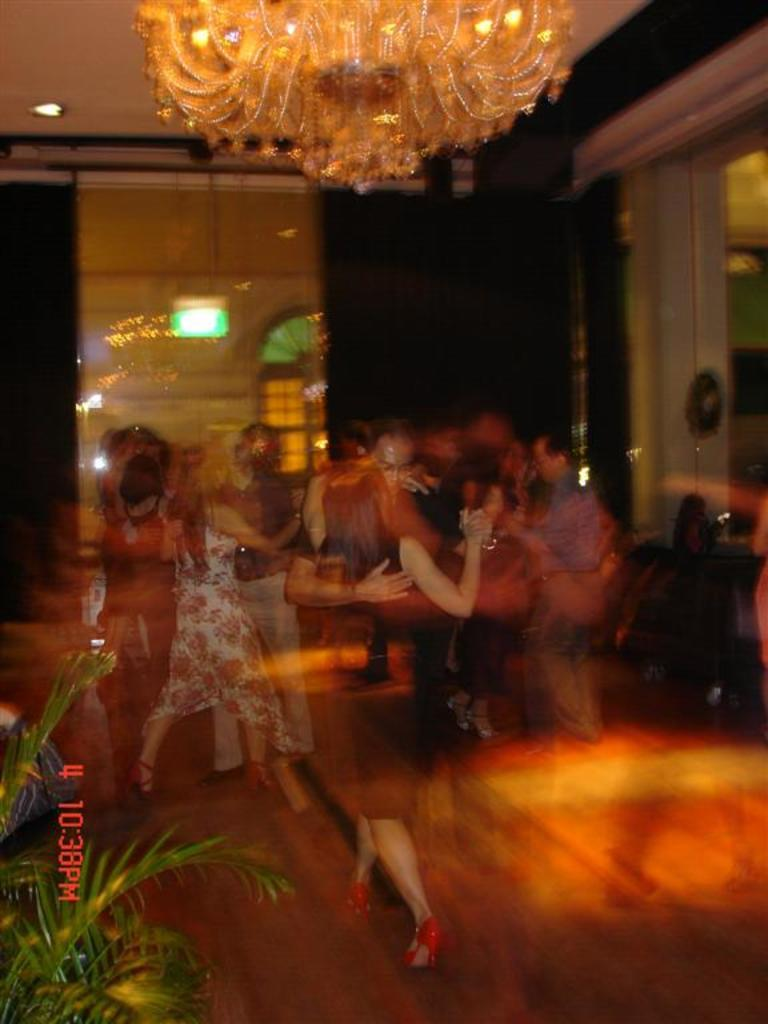What are the people in the image doing? There are people dancing in the center of the image. What can be seen at the top of the image? There is a chandelier at the top of the image. What is located at the bottom of the image? There is a plant at the bottom of the image. What is visible in the background of the image? There is a wall in the background of the image. What type of gate can be seen in the image? There is no gate present in the image. What type of education is being taught in the image? There is no educational activity depicted in the image; it features people dancing. 